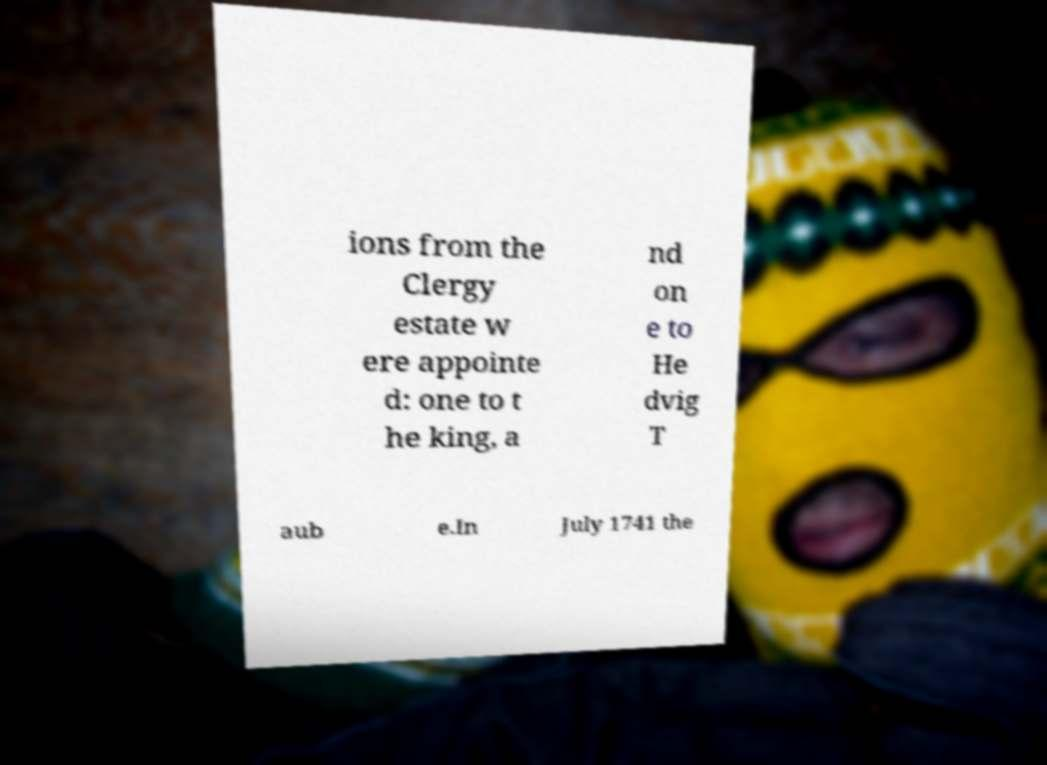Please read and relay the text visible in this image. What does it say? ions from the Clergy estate w ere appointe d: one to t he king, a nd on e to He dvig T aub e.In July 1741 the 